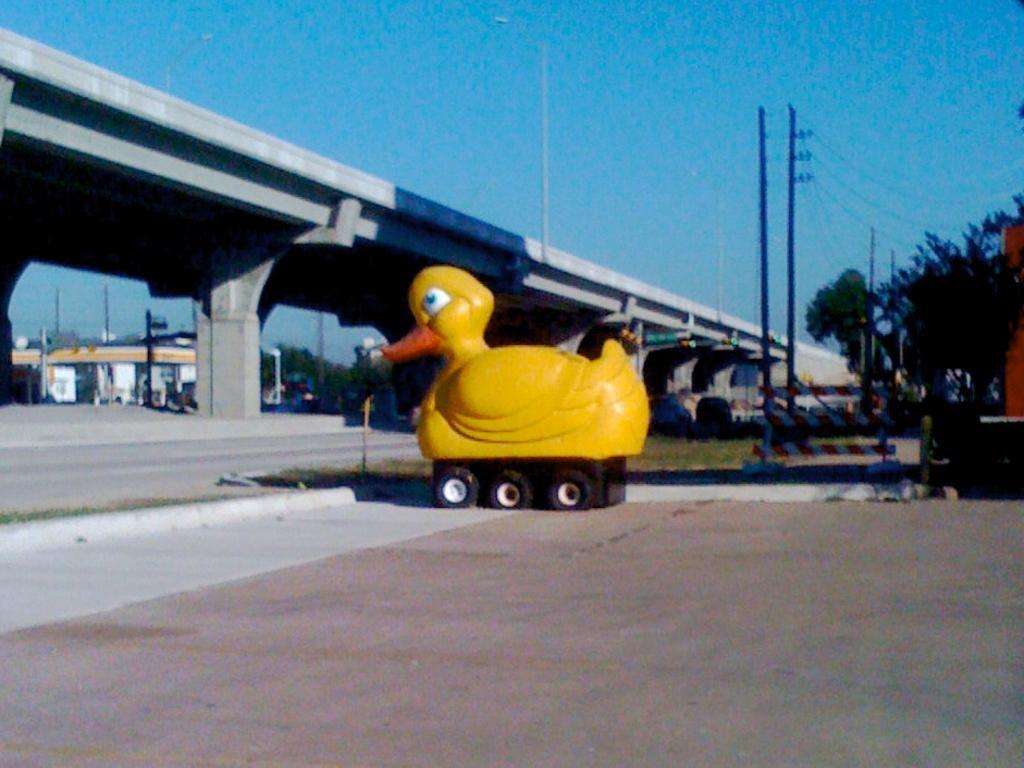In one or two sentences, can you explain what this image depicts? In this image in the center there is one toy, and in the background there is a bridge, pillars, poles, trees, wires, lights. And at the bottom there is a walkway and at the top of the image there is sky. 